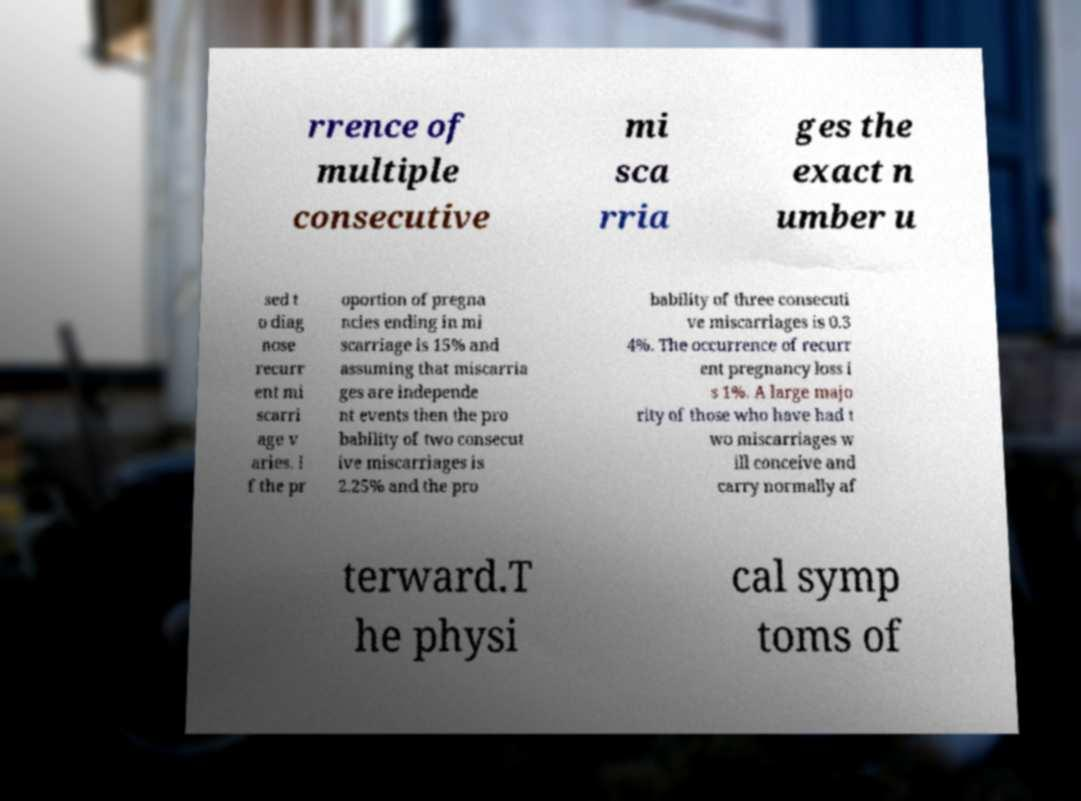Can you accurately transcribe the text from the provided image for me? rrence of multiple consecutive mi sca rria ges the exact n umber u sed t o diag nose recurr ent mi scarri age v aries. I f the pr oportion of pregna ncies ending in mi scarriage is 15% and assuming that miscarria ges are independe nt events then the pro bability of two consecut ive miscarriages is 2.25% and the pro bability of three consecuti ve miscarriages is 0.3 4%. The occurrence of recurr ent pregnancy loss i s 1%. A large majo rity of those who have had t wo miscarriages w ill conceive and carry normally af terward.T he physi cal symp toms of 